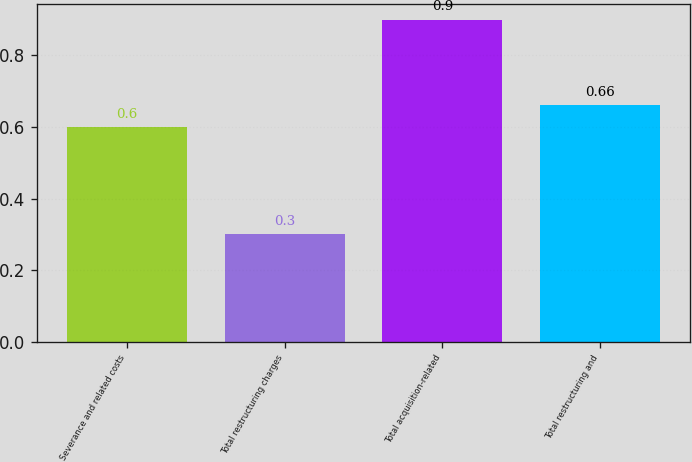Convert chart to OTSL. <chart><loc_0><loc_0><loc_500><loc_500><bar_chart><fcel>Severance and related costs<fcel>Total restructuring charges<fcel>Total acquisition-related<fcel>Total restructuring and<nl><fcel>0.6<fcel>0.3<fcel>0.9<fcel>0.66<nl></chart> 